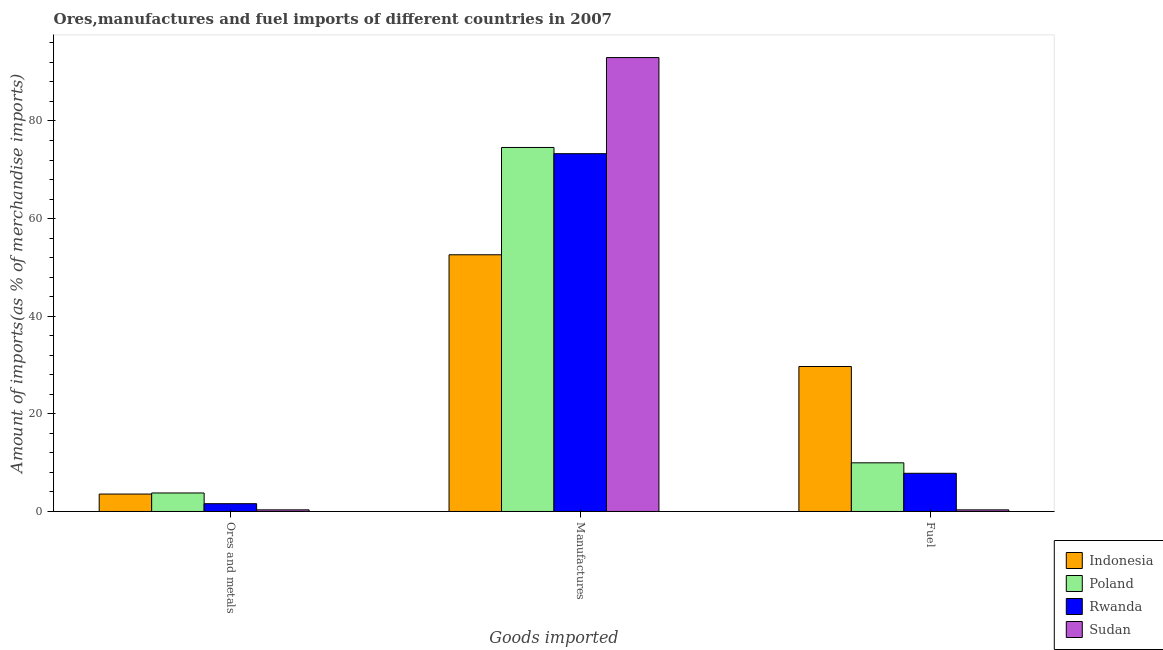Are the number of bars per tick equal to the number of legend labels?
Your answer should be very brief. Yes. How many bars are there on the 3rd tick from the left?
Offer a very short reply. 4. How many bars are there on the 1st tick from the right?
Your answer should be very brief. 4. What is the label of the 3rd group of bars from the left?
Make the answer very short. Fuel. What is the percentage of fuel imports in Sudan?
Your response must be concise. 0.33. Across all countries, what is the maximum percentage of fuel imports?
Provide a succinct answer. 29.7. Across all countries, what is the minimum percentage of fuel imports?
Your answer should be very brief. 0.33. In which country was the percentage of manufactures imports maximum?
Your answer should be compact. Sudan. In which country was the percentage of fuel imports minimum?
Provide a short and direct response. Sudan. What is the total percentage of manufactures imports in the graph?
Make the answer very short. 293.46. What is the difference between the percentage of fuel imports in Rwanda and that in Poland?
Offer a terse response. -2.15. What is the difference between the percentage of manufactures imports in Sudan and the percentage of fuel imports in Rwanda?
Your answer should be very brief. 85.17. What is the average percentage of ores and metals imports per country?
Ensure brevity in your answer.  2.32. What is the difference between the percentage of fuel imports and percentage of ores and metals imports in Sudan?
Your answer should be very brief. -0. What is the ratio of the percentage of manufactures imports in Sudan to that in Rwanda?
Provide a short and direct response. 1.27. Is the percentage of manufactures imports in Indonesia less than that in Sudan?
Give a very brief answer. Yes. Is the difference between the percentage of manufactures imports in Rwanda and Poland greater than the difference between the percentage of ores and metals imports in Rwanda and Poland?
Offer a very short reply. Yes. What is the difference between the highest and the second highest percentage of ores and metals imports?
Your answer should be compact. 0.22. What is the difference between the highest and the lowest percentage of manufactures imports?
Make the answer very short. 40.4. What does the 3rd bar from the left in Fuel represents?
Provide a succinct answer. Rwanda. What does the 3rd bar from the right in Fuel represents?
Give a very brief answer. Poland. What is the difference between two consecutive major ticks on the Y-axis?
Offer a very short reply. 20. Are the values on the major ticks of Y-axis written in scientific E-notation?
Make the answer very short. No. Where does the legend appear in the graph?
Make the answer very short. Bottom right. How many legend labels are there?
Offer a very short reply. 4. How are the legend labels stacked?
Give a very brief answer. Vertical. What is the title of the graph?
Make the answer very short. Ores,manufactures and fuel imports of different countries in 2007. What is the label or title of the X-axis?
Your answer should be compact. Goods imported. What is the label or title of the Y-axis?
Offer a terse response. Amount of imports(as % of merchandise imports). What is the Amount of imports(as % of merchandise imports) of Indonesia in Ores and metals?
Keep it short and to the point. 3.57. What is the Amount of imports(as % of merchandise imports) of Poland in Ores and metals?
Give a very brief answer. 3.79. What is the Amount of imports(as % of merchandise imports) in Rwanda in Ores and metals?
Offer a very short reply. 1.6. What is the Amount of imports(as % of merchandise imports) in Sudan in Ores and metals?
Provide a short and direct response. 0.33. What is the Amount of imports(as % of merchandise imports) of Indonesia in Manufactures?
Provide a succinct answer. 52.59. What is the Amount of imports(as % of merchandise imports) in Poland in Manufactures?
Your answer should be compact. 74.57. What is the Amount of imports(as % of merchandise imports) of Rwanda in Manufactures?
Make the answer very short. 73.3. What is the Amount of imports(as % of merchandise imports) in Sudan in Manufactures?
Provide a succinct answer. 92.99. What is the Amount of imports(as % of merchandise imports) of Indonesia in Fuel?
Make the answer very short. 29.7. What is the Amount of imports(as % of merchandise imports) in Poland in Fuel?
Give a very brief answer. 9.97. What is the Amount of imports(as % of merchandise imports) of Rwanda in Fuel?
Provide a short and direct response. 7.82. What is the Amount of imports(as % of merchandise imports) of Sudan in Fuel?
Your response must be concise. 0.33. Across all Goods imported, what is the maximum Amount of imports(as % of merchandise imports) in Indonesia?
Make the answer very short. 52.59. Across all Goods imported, what is the maximum Amount of imports(as % of merchandise imports) of Poland?
Offer a very short reply. 74.57. Across all Goods imported, what is the maximum Amount of imports(as % of merchandise imports) of Rwanda?
Keep it short and to the point. 73.3. Across all Goods imported, what is the maximum Amount of imports(as % of merchandise imports) of Sudan?
Provide a succinct answer. 92.99. Across all Goods imported, what is the minimum Amount of imports(as % of merchandise imports) of Indonesia?
Offer a very short reply. 3.57. Across all Goods imported, what is the minimum Amount of imports(as % of merchandise imports) of Poland?
Give a very brief answer. 3.79. Across all Goods imported, what is the minimum Amount of imports(as % of merchandise imports) of Rwanda?
Keep it short and to the point. 1.6. Across all Goods imported, what is the minimum Amount of imports(as % of merchandise imports) in Sudan?
Your answer should be compact. 0.33. What is the total Amount of imports(as % of merchandise imports) in Indonesia in the graph?
Provide a succinct answer. 85.87. What is the total Amount of imports(as % of merchandise imports) in Poland in the graph?
Offer a very short reply. 88.33. What is the total Amount of imports(as % of merchandise imports) of Rwanda in the graph?
Offer a very short reply. 82.72. What is the total Amount of imports(as % of merchandise imports) of Sudan in the graph?
Your answer should be compact. 93.66. What is the difference between the Amount of imports(as % of merchandise imports) of Indonesia in Ores and metals and that in Manufactures?
Offer a very short reply. -49.02. What is the difference between the Amount of imports(as % of merchandise imports) of Poland in Ores and metals and that in Manufactures?
Your response must be concise. -70.78. What is the difference between the Amount of imports(as % of merchandise imports) of Rwanda in Ores and metals and that in Manufactures?
Ensure brevity in your answer.  -71.71. What is the difference between the Amount of imports(as % of merchandise imports) in Sudan in Ores and metals and that in Manufactures?
Give a very brief answer. -92.66. What is the difference between the Amount of imports(as % of merchandise imports) of Indonesia in Ores and metals and that in Fuel?
Your answer should be very brief. -26.13. What is the difference between the Amount of imports(as % of merchandise imports) of Poland in Ores and metals and that in Fuel?
Make the answer very short. -6.18. What is the difference between the Amount of imports(as % of merchandise imports) of Rwanda in Ores and metals and that in Fuel?
Ensure brevity in your answer.  -6.23. What is the difference between the Amount of imports(as % of merchandise imports) in Sudan in Ores and metals and that in Fuel?
Your response must be concise. 0. What is the difference between the Amount of imports(as % of merchandise imports) of Indonesia in Manufactures and that in Fuel?
Keep it short and to the point. 22.89. What is the difference between the Amount of imports(as % of merchandise imports) in Poland in Manufactures and that in Fuel?
Keep it short and to the point. 64.6. What is the difference between the Amount of imports(as % of merchandise imports) in Rwanda in Manufactures and that in Fuel?
Give a very brief answer. 65.48. What is the difference between the Amount of imports(as % of merchandise imports) of Sudan in Manufactures and that in Fuel?
Offer a very short reply. 92.66. What is the difference between the Amount of imports(as % of merchandise imports) of Indonesia in Ores and metals and the Amount of imports(as % of merchandise imports) of Poland in Manufactures?
Ensure brevity in your answer.  -71. What is the difference between the Amount of imports(as % of merchandise imports) in Indonesia in Ores and metals and the Amount of imports(as % of merchandise imports) in Rwanda in Manufactures?
Your answer should be very brief. -69.73. What is the difference between the Amount of imports(as % of merchandise imports) of Indonesia in Ores and metals and the Amount of imports(as % of merchandise imports) of Sudan in Manufactures?
Provide a short and direct response. -89.42. What is the difference between the Amount of imports(as % of merchandise imports) in Poland in Ores and metals and the Amount of imports(as % of merchandise imports) in Rwanda in Manufactures?
Offer a terse response. -69.51. What is the difference between the Amount of imports(as % of merchandise imports) of Poland in Ores and metals and the Amount of imports(as % of merchandise imports) of Sudan in Manufactures?
Offer a very short reply. -89.2. What is the difference between the Amount of imports(as % of merchandise imports) in Rwanda in Ores and metals and the Amount of imports(as % of merchandise imports) in Sudan in Manufactures?
Your answer should be very brief. -91.39. What is the difference between the Amount of imports(as % of merchandise imports) of Indonesia in Ores and metals and the Amount of imports(as % of merchandise imports) of Poland in Fuel?
Make the answer very short. -6.4. What is the difference between the Amount of imports(as % of merchandise imports) in Indonesia in Ores and metals and the Amount of imports(as % of merchandise imports) in Rwanda in Fuel?
Offer a very short reply. -4.25. What is the difference between the Amount of imports(as % of merchandise imports) in Indonesia in Ores and metals and the Amount of imports(as % of merchandise imports) in Sudan in Fuel?
Offer a very short reply. 3.24. What is the difference between the Amount of imports(as % of merchandise imports) of Poland in Ores and metals and the Amount of imports(as % of merchandise imports) of Rwanda in Fuel?
Offer a very short reply. -4.03. What is the difference between the Amount of imports(as % of merchandise imports) of Poland in Ores and metals and the Amount of imports(as % of merchandise imports) of Sudan in Fuel?
Offer a very short reply. 3.46. What is the difference between the Amount of imports(as % of merchandise imports) of Rwanda in Ores and metals and the Amount of imports(as % of merchandise imports) of Sudan in Fuel?
Give a very brief answer. 1.27. What is the difference between the Amount of imports(as % of merchandise imports) of Indonesia in Manufactures and the Amount of imports(as % of merchandise imports) of Poland in Fuel?
Make the answer very short. 42.62. What is the difference between the Amount of imports(as % of merchandise imports) of Indonesia in Manufactures and the Amount of imports(as % of merchandise imports) of Rwanda in Fuel?
Offer a terse response. 44.77. What is the difference between the Amount of imports(as % of merchandise imports) of Indonesia in Manufactures and the Amount of imports(as % of merchandise imports) of Sudan in Fuel?
Provide a short and direct response. 52.26. What is the difference between the Amount of imports(as % of merchandise imports) in Poland in Manufactures and the Amount of imports(as % of merchandise imports) in Rwanda in Fuel?
Make the answer very short. 66.75. What is the difference between the Amount of imports(as % of merchandise imports) in Poland in Manufactures and the Amount of imports(as % of merchandise imports) in Sudan in Fuel?
Your answer should be very brief. 74.24. What is the difference between the Amount of imports(as % of merchandise imports) of Rwanda in Manufactures and the Amount of imports(as % of merchandise imports) of Sudan in Fuel?
Your response must be concise. 72.97. What is the average Amount of imports(as % of merchandise imports) of Indonesia per Goods imported?
Offer a terse response. 28.62. What is the average Amount of imports(as % of merchandise imports) of Poland per Goods imported?
Make the answer very short. 29.44. What is the average Amount of imports(as % of merchandise imports) in Rwanda per Goods imported?
Provide a succinct answer. 27.57. What is the average Amount of imports(as % of merchandise imports) in Sudan per Goods imported?
Your response must be concise. 31.22. What is the difference between the Amount of imports(as % of merchandise imports) of Indonesia and Amount of imports(as % of merchandise imports) of Poland in Ores and metals?
Your response must be concise. -0.22. What is the difference between the Amount of imports(as % of merchandise imports) of Indonesia and Amount of imports(as % of merchandise imports) of Rwanda in Ores and metals?
Give a very brief answer. 1.97. What is the difference between the Amount of imports(as % of merchandise imports) in Indonesia and Amount of imports(as % of merchandise imports) in Sudan in Ores and metals?
Keep it short and to the point. 3.24. What is the difference between the Amount of imports(as % of merchandise imports) of Poland and Amount of imports(as % of merchandise imports) of Rwanda in Ores and metals?
Make the answer very short. 2.19. What is the difference between the Amount of imports(as % of merchandise imports) in Poland and Amount of imports(as % of merchandise imports) in Sudan in Ores and metals?
Provide a succinct answer. 3.46. What is the difference between the Amount of imports(as % of merchandise imports) in Rwanda and Amount of imports(as % of merchandise imports) in Sudan in Ores and metals?
Offer a very short reply. 1.26. What is the difference between the Amount of imports(as % of merchandise imports) in Indonesia and Amount of imports(as % of merchandise imports) in Poland in Manufactures?
Your response must be concise. -21.98. What is the difference between the Amount of imports(as % of merchandise imports) in Indonesia and Amount of imports(as % of merchandise imports) in Rwanda in Manufactures?
Provide a short and direct response. -20.71. What is the difference between the Amount of imports(as % of merchandise imports) in Indonesia and Amount of imports(as % of merchandise imports) in Sudan in Manufactures?
Provide a short and direct response. -40.4. What is the difference between the Amount of imports(as % of merchandise imports) of Poland and Amount of imports(as % of merchandise imports) of Rwanda in Manufactures?
Your answer should be very brief. 1.27. What is the difference between the Amount of imports(as % of merchandise imports) in Poland and Amount of imports(as % of merchandise imports) in Sudan in Manufactures?
Your response must be concise. -18.42. What is the difference between the Amount of imports(as % of merchandise imports) of Rwanda and Amount of imports(as % of merchandise imports) of Sudan in Manufactures?
Keep it short and to the point. -19.69. What is the difference between the Amount of imports(as % of merchandise imports) in Indonesia and Amount of imports(as % of merchandise imports) in Poland in Fuel?
Your response must be concise. 19.73. What is the difference between the Amount of imports(as % of merchandise imports) in Indonesia and Amount of imports(as % of merchandise imports) in Rwanda in Fuel?
Your answer should be very brief. 21.88. What is the difference between the Amount of imports(as % of merchandise imports) of Indonesia and Amount of imports(as % of merchandise imports) of Sudan in Fuel?
Provide a short and direct response. 29.37. What is the difference between the Amount of imports(as % of merchandise imports) of Poland and Amount of imports(as % of merchandise imports) of Rwanda in Fuel?
Offer a very short reply. 2.15. What is the difference between the Amount of imports(as % of merchandise imports) of Poland and Amount of imports(as % of merchandise imports) of Sudan in Fuel?
Keep it short and to the point. 9.64. What is the difference between the Amount of imports(as % of merchandise imports) of Rwanda and Amount of imports(as % of merchandise imports) of Sudan in Fuel?
Ensure brevity in your answer.  7.49. What is the ratio of the Amount of imports(as % of merchandise imports) in Indonesia in Ores and metals to that in Manufactures?
Your response must be concise. 0.07. What is the ratio of the Amount of imports(as % of merchandise imports) in Poland in Ores and metals to that in Manufactures?
Your answer should be compact. 0.05. What is the ratio of the Amount of imports(as % of merchandise imports) of Rwanda in Ores and metals to that in Manufactures?
Ensure brevity in your answer.  0.02. What is the ratio of the Amount of imports(as % of merchandise imports) in Sudan in Ores and metals to that in Manufactures?
Offer a very short reply. 0. What is the ratio of the Amount of imports(as % of merchandise imports) of Indonesia in Ores and metals to that in Fuel?
Ensure brevity in your answer.  0.12. What is the ratio of the Amount of imports(as % of merchandise imports) in Poland in Ores and metals to that in Fuel?
Provide a short and direct response. 0.38. What is the ratio of the Amount of imports(as % of merchandise imports) of Rwanda in Ores and metals to that in Fuel?
Provide a short and direct response. 0.2. What is the ratio of the Amount of imports(as % of merchandise imports) in Sudan in Ores and metals to that in Fuel?
Offer a very short reply. 1.01. What is the ratio of the Amount of imports(as % of merchandise imports) in Indonesia in Manufactures to that in Fuel?
Your answer should be very brief. 1.77. What is the ratio of the Amount of imports(as % of merchandise imports) of Poland in Manufactures to that in Fuel?
Keep it short and to the point. 7.48. What is the ratio of the Amount of imports(as % of merchandise imports) of Rwanda in Manufactures to that in Fuel?
Give a very brief answer. 9.37. What is the ratio of the Amount of imports(as % of merchandise imports) in Sudan in Manufactures to that in Fuel?
Give a very brief answer. 281.16. What is the difference between the highest and the second highest Amount of imports(as % of merchandise imports) in Indonesia?
Provide a succinct answer. 22.89. What is the difference between the highest and the second highest Amount of imports(as % of merchandise imports) in Poland?
Give a very brief answer. 64.6. What is the difference between the highest and the second highest Amount of imports(as % of merchandise imports) in Rwanda?
Keep it short and to the point. 65.48. What is the difference between the highest and the second highest Amount of imports(as % of merchandise imports) in Sudan?
Offer a terse response. 92.66. What is the difference between the highest and the lowest Amount of imports(as % of merchandise imports) in Indonesia?
Keep it short and to the point. 49.02. What is the difference between the highest and the lowest Amount of imports(as % of merchandise imports) of Poland?
Make the answer very short. 70.78. What is the difference between the highest and the lowest Amount of imports(as % of merchandise imports) of Rwanda?
Keep it short and to the point. 71.71. What is the difference between the highest and the lowest Amount of imports(as % of merchandise imports) of Sudan?
Your response must be concise. 92.66. 